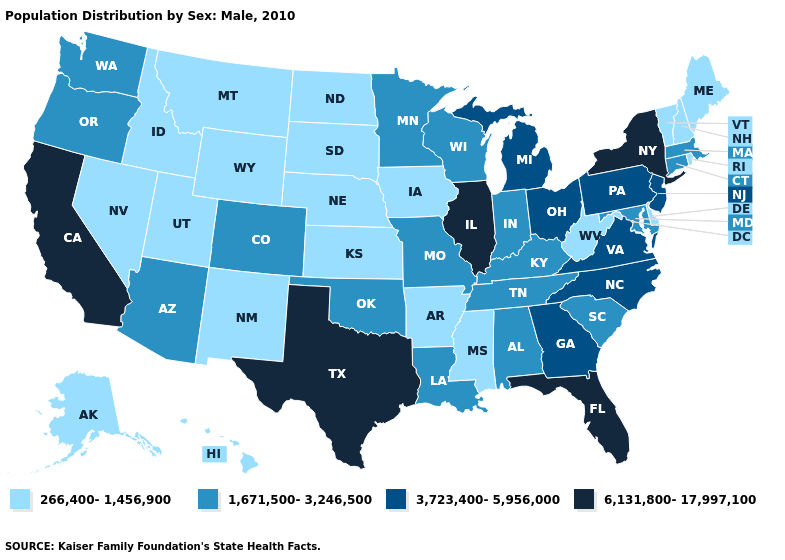What is the highest value in states that border Indiana?
Quick response, please. 6,131,800-17,997,100. Name the states that have a value in the range 266,400-1,456,900?
Keep it brief. Alaska, Arkansas, Delaware, Hawaii, Idaho, Iowa, Kansas, Maine, Mississippi, Montana, Nebraska, Nevada, New Hampshire, New Mexico, North Dakota, Rhode Island, South Dakota, Utah, Vermont, West Virginia, Wyoming. What is the value of Florida?
Give a very brief answer. 6,131,800-17,997,100. What is the highest value in states that border Utah?
Be succinct. 1,671,500-3,246,500. Does the first symbol in the legend represent the smallest category?
Be succinct. Yes. What is the highest value in states that border Wisconsin?
Quick response, please. 6,131,800-17,997,100. Does Illinois have the highest value in the USA?
Write a very short answer. Yes. Which states hav the highest value in the South?
Short answer required. Florida, Texas. What is the value of Hawaii?
Keep it brief. 266,400-1,456,900. What is the lowest value in the South?
Concise answer only. 266,400-1,456,900. Name the states that have a value in the range 6,131,800-17,997,100?
Keep it brief. California, Florida, Illinois, New York, Texas. Among the states that border Michigan , which have the highest value?
Short answer required. Ohio. What is the value of Ohio?
Short answer required. 3,723,400-5,956,000. Does the map have missing data?
Quick response, please. No. Does Texas have the highest value in the USA?
Give a very brief answer. Yes. 